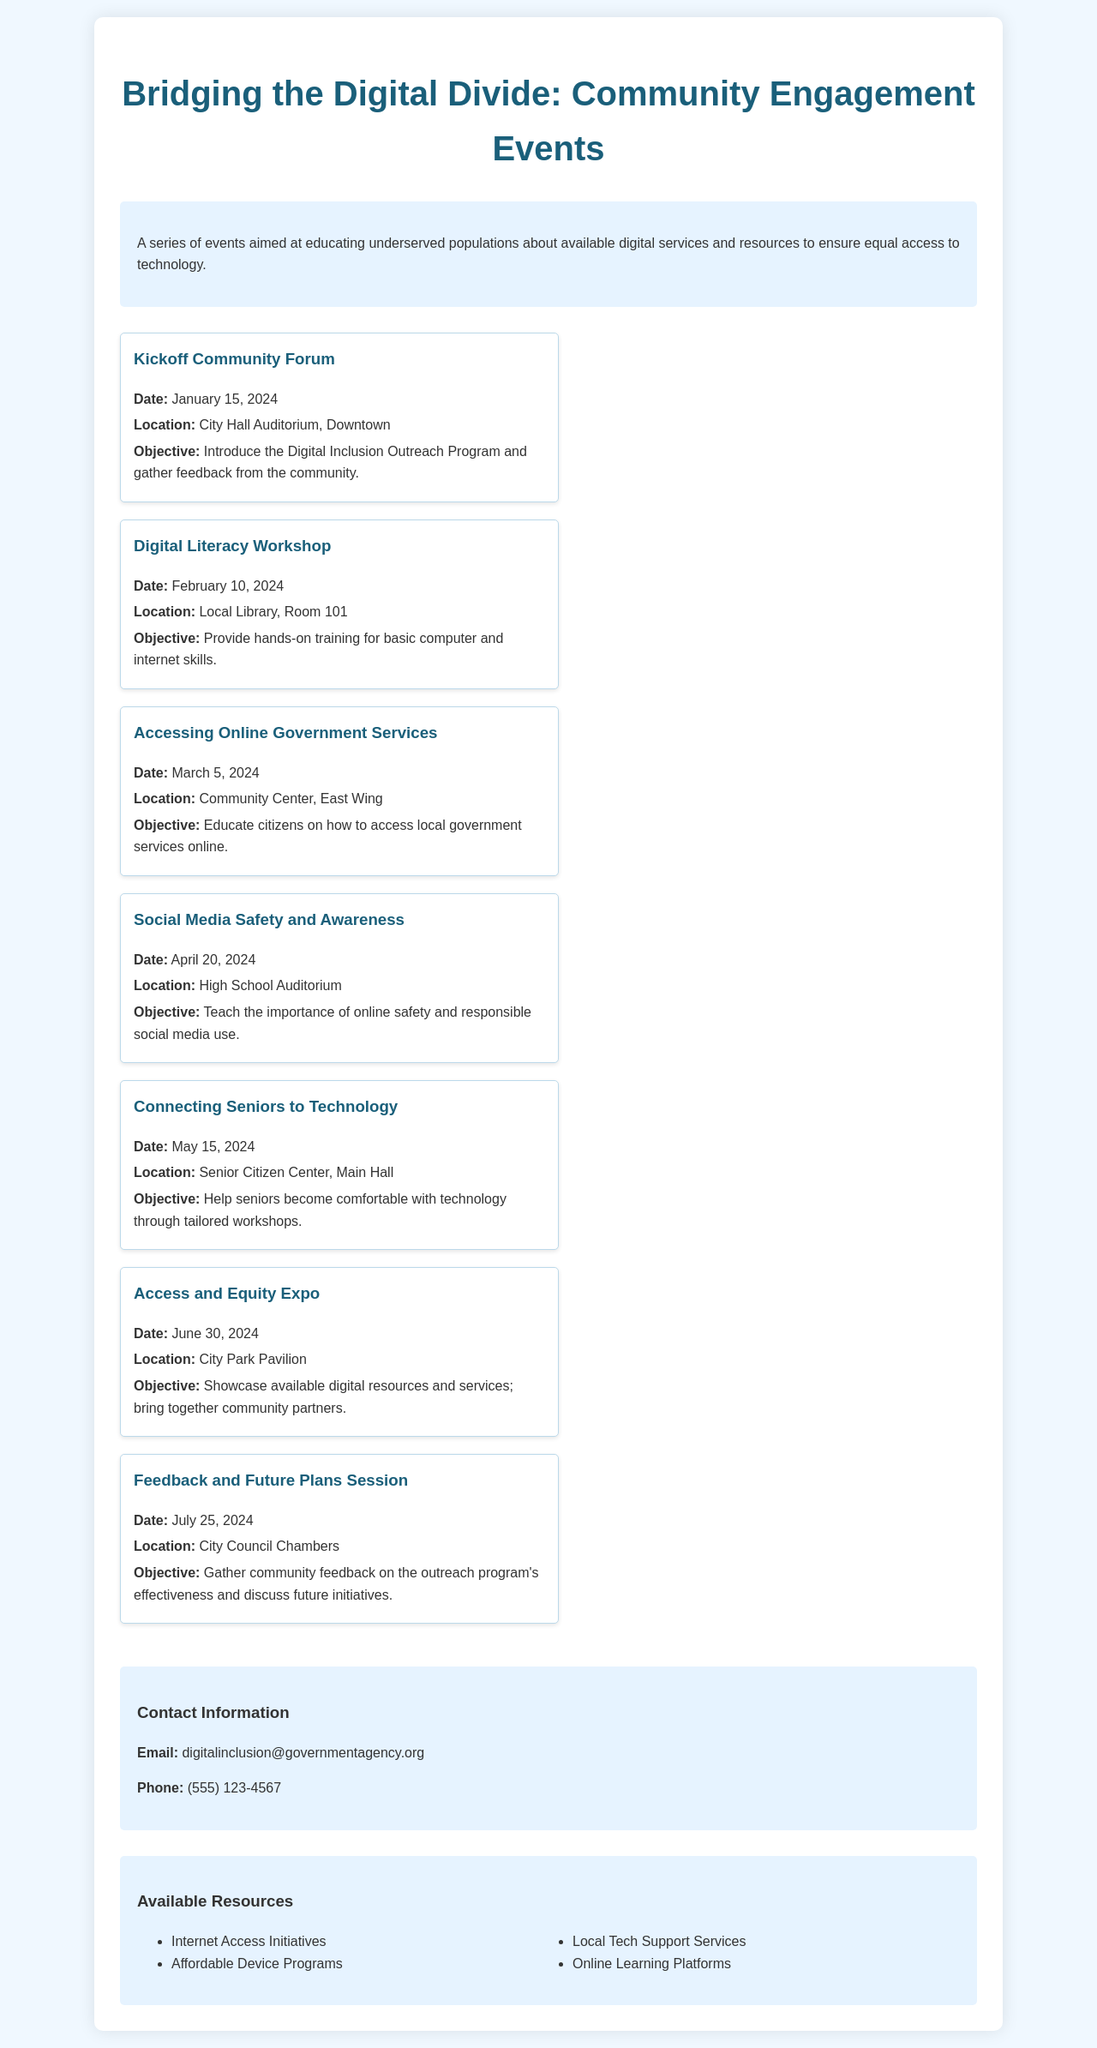What is the date of the Kickoff Community Forum? The document states the date of the Kickoff Community Forum is January 15, 2024.
Answer: January 15, 2024 Where will the Digital Literacy Workshop take place? The Digital Literacy Workshop will take place at the Local Library, Room 101.
Answer: Local Library, Room 101 What is the objective of the Accessing Online Government Services event? The objective of this event is to educate citizens on how to access local government services online.
Answer: Educate citizens on how to access local government services online What is the last event scheduled in the timeline? The last event scheduled is the Feedback and Future Plans Session on July 25, 2024.
Answer: Feedback and Future Plans Session How many events are listed in the schedule? The document lists a total of seven community engagement events.
Answer: Seven What type of resources are mentioned in the document? The document mentions internet access initiatives, affordable device programs, local tech support services, and online learning platforms.
Answer: Internet Access Initiatives, Affordable Device Programs, Local Tech Support Services, Online Learning Platforms What is the purpose of the Access and Equity Expo? The purpose is to showcase available digital resources and services and bring together community partners.
Answer: Showcase available digital resources and services; bring together community partners Who can be contacted for more information about the program? The document provides an email and phone number as contact information for more inquiries.
Answer: digitalinclusion@governmentagency.org, (555) 123-4567 